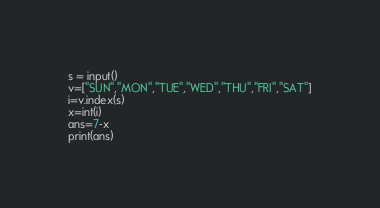<code> <loc_0><loc_0><loc_500><loc_500><_Python_>s = input()
v=["SUN","MON","TUE","WED","THU","FRI","SAT"]
i=v.index(s)
x=int(i)
ans=7-x
print(ans)</code> 